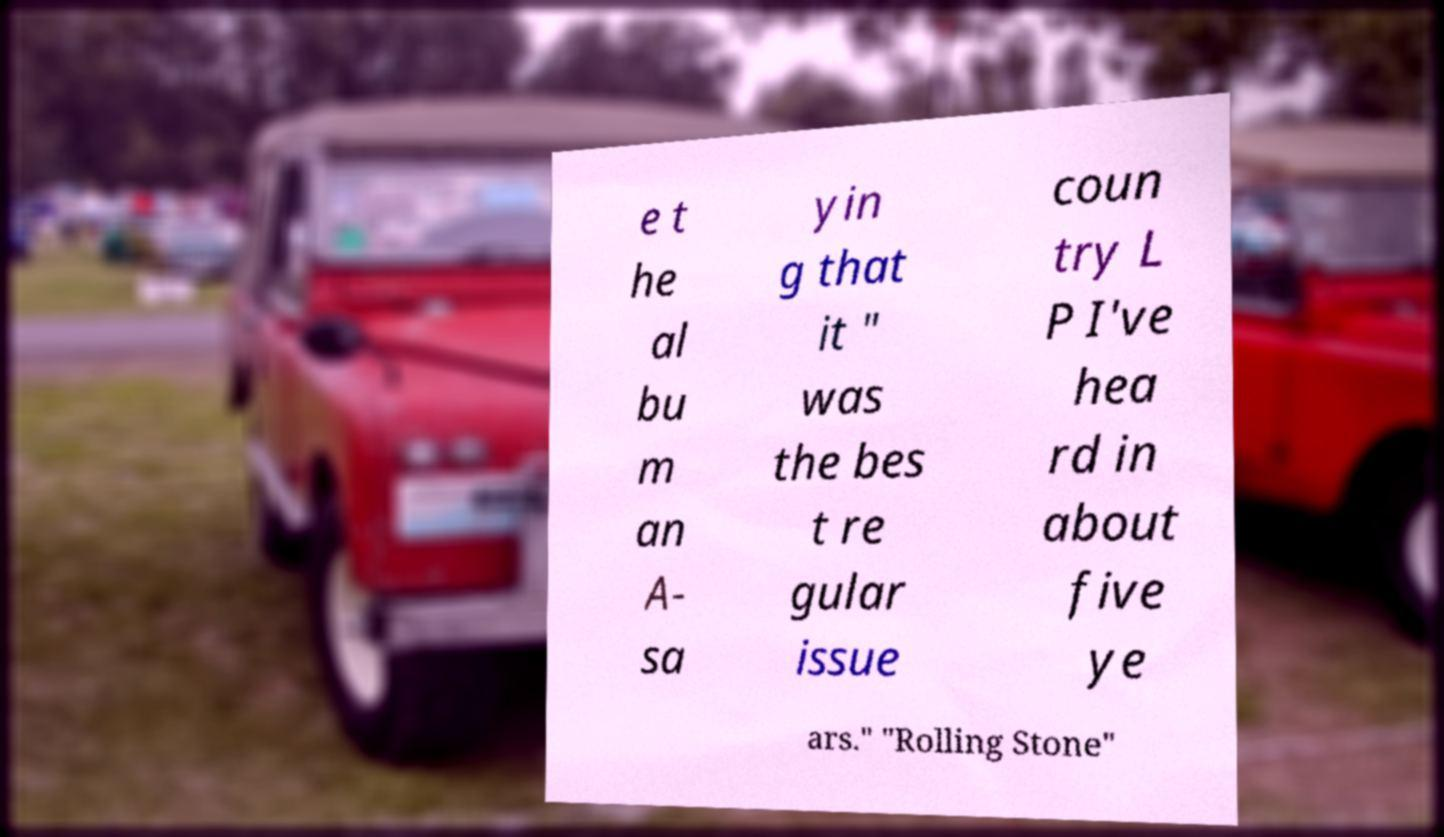Could you extract and type out the text from this image? e t he al bu m an A- sa yin g that it " was the bes t re gular issue coun try L P I've hea rd in about five ye ars." "Rolling Stone" 